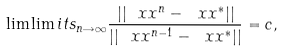Convert formula to latex. <formula><loc_0><loc_0><loc_500><loc_500>\lim \lim i t s _ { n \rightarrow \infty } \frac { | | \ x x ^ { n } - \ x x ^ { \ast } | | } { | | \ x x ^ { n - 1 } - \ x x ^ { \ast } | | } = c ,</formula> 